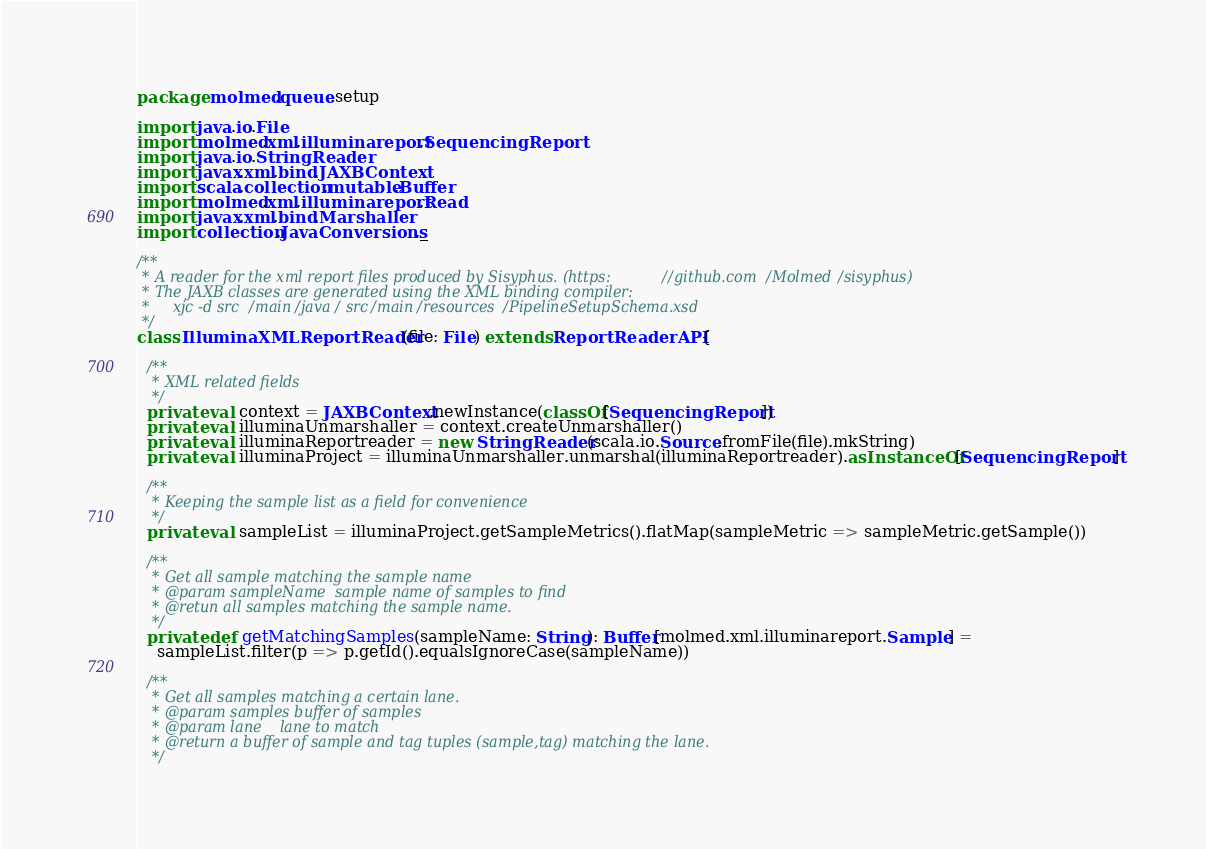Convert code to text. <code><loc_0><loc_0><loc_500><loc_500><_Scala_>package molmed.queue.setup

import java.io.File
import molmed.xml.illuminareport.SequencingReport
import java.io.StringReader
import javax.xml.bind.JAXBContext
import scala.collection.mutable.Buffer
import molmed.xml.illuminareport.Read
import javax.xml.bind.Marshaller
import collection.JavaConversions._

/**
 * A reader for the xml report files produced by Sisyphus. (https://github.com/Molmed/sisyphus)
 * The JAXB classes are generated using the XML binding compiler:
 *     xjc -d src/main/java/ src/main/resources/PipelineSetupSchema.xsd
 */
class IlluminaXMLReportReader(file: File) extends ReportReaderAPI {

  /**
   * XML related fields
   */
  private val context = JAXBContext.newInstance(classOf[SequencingReport])
  private val illuminaUnmarshaller = context.createUnmarshaller()
  private val illuminaReportreader = new StringReader(scala.io.Source.fromFile(file).mkString)
  private val illuminaProject = illuminaUnmarshaller.unmarshal(illuminaReportreader).asInstanceOf[SequencingReport]

  /**
   * Keeping the sample list as a field for convenience
   */
  private val sampleList = illuminaProject.getSampleMetrics().flatMap(sampleMetric => sampleMetric.getSample())

  /**
   * Get all sample matching the sample name
   * @param sampleName	sample name of samples to find
   * @retun all samples matching the sample name.
   */
  private def getMatchingSamples(sampleName: String): Buffer[molmed.xml.illuminareport.Sample] =
    sampleList.filter(p => p.getId().equalsIgnoreCase(sampleName))

  /**
   * Get all samples matching a certain lane.
   * @param samples	buffer of samples
   * @param lane	lane to match
   * @return a buffer of sample and tag tuples (sample,tag) matching the lane.
   */</code> 